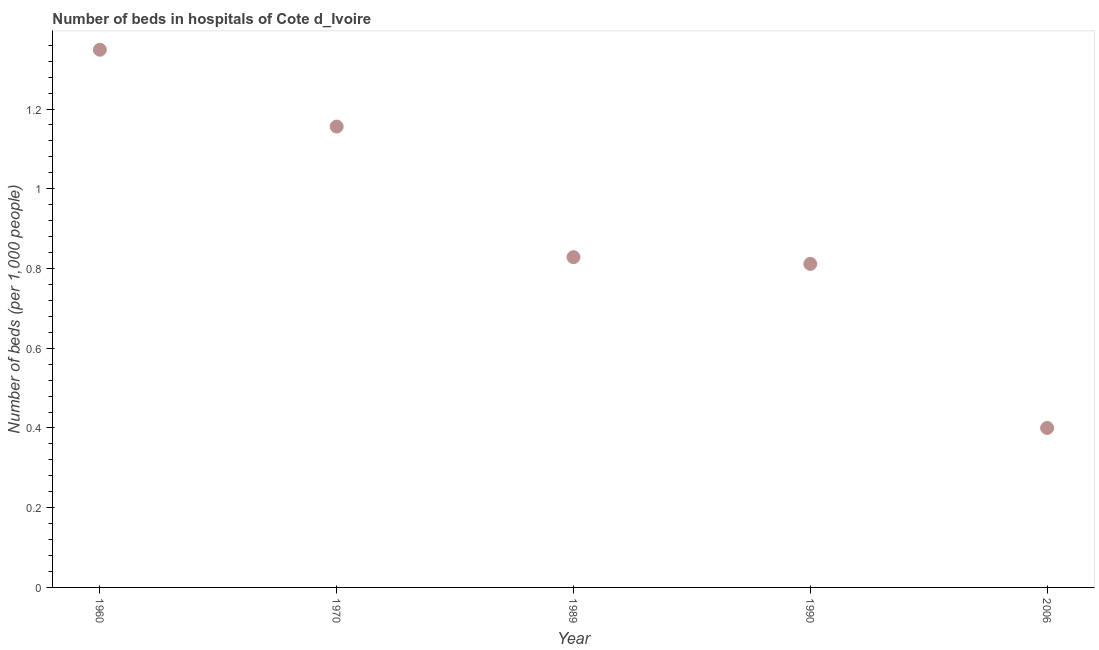What is the number of hospital beds in 1970?
Your answer should be compact. 1.16. Across all years, what is the maximum number of hospital beds?
Provide a short and direct response. 1.35. In which year was the number of hospital beds minimum?
Provide a short and direct response. 2006. What is the sum of the number of hospital beds?
Your answer should be very brief. 4.54. What is the difference between the number of hospital beds in 1990 and 2006?
Keep it short and to the point. 0.41. What is the average number of hospital beds per year?
Keep it short and to the point. 0.91. What is the median number of hospital beds?
Make the answer very short. 0.83. In how many years, is the number of hospital beds greater than 0.8 %?
Your response must be concise. 4. What is the ratio of the number of hospital beds in 1960 to that in 1970?
Your response must be concise. 1.17. Is the number of hospital beds in 1960 less than that in 1989?
Give a very brief answer. No. Is the difference between the number of hospital beds in 1970 and 1989 greater than the difference between any two years?
Your response must be concise. No. What is the difference between the highest and the second highest number of hospital beds?
Provide a short and direct response. 0.19. What is the difference between the highest and the lowest number of hospital beds?
Your answer should be very brief. 0.95. Does the number of hospital beds monotonically increase over the years?
Your response must be concise. No. What is the difference between two consecutive major ticks on the Y-axis?
Ensure brevity in your answer.  0.2. Are the values on the major ticks of Y-axis written in scientific E-notation?
Offer a very short reply. No. Does the graph contain grids?
Offer a terse response. No. What is the title of the graph?
Your answer should be compact. Number of beds in hospitals of Cote d_Ivoire. What is the label or title of the Y-axis?
Give a very brief answer. Number of beds (per 1,0 people). What is the Number of beds (per 1,000 people) in 1960?
Offer a very short reply. 1.35. What is the Number of beds (per 1,000 people) in 1970?
Your answer should be very brief. 1.16. What is the Number of beds (per 1,000 people) in 1989?
Give a very brief answer. 0.83. What is the Number of beds (per 1,000 people) in 1990?
Give a very brief answer. 0.81. What is the difference between the Number of beds (per 1,000 people) in 1960 and 1970?
Your response must be concise. 0.19. What is the difference between the Number of beds (per 1,000 people) in 1960 and 1989?
Offer a very short reply. 0.52. What is the difference between the Number of beds (per 1,000 people) in 1960 and 1990?
Provide a succinct answer. 0.54. What is the difference between the Number of beds (per 1,000 people) in 1960 and 2006?
Offer a terse response. 0.95. What is the difference between the Number of beds (per 1,000 people) in 1970 and 1989?
Ensure brevity in your answer.  0.33. What is the difference between the Number of beds (per 1,000 people) in 1970 and 1990?
Provide a succinct answer. 0.34. What is the difference between the Number of beds (per 1,000 people) in 1970 and 2006?
Ensure brevity in your answer.  0.76. What is the difference between the Number of beds (per 1,000 people) in 1989 and 1990?
Your answer should be compact. 0.02. What is the difference between the Number of beds (per 1,000 people) in 1989 and 2006?
Keep it short and to the point. 0.43. What is the difference between the Number of beds (per 1,000 people) in 1990 and 2006?
Your answer should be compact. 0.41. What is the ratio of the Number of beds (per 1,000 people) in 1960 to that in 1970?
Provide a succinct answer. 1.17. What is the ratio of the Number of beds (per 1,000 people) in 1960 to that in 1989?
Your response must be concise. 1.63. What is the ratio of the Number of beds (per 1,000 people) in 1960 to that in 1990?
Your answer should be very brief. 1.66. What is the ratio of the Number of beds (per 1,000 people) in 1960 to that in 2006?
Your answer should be compact. 3.37. What is the ratio of the Number of beds (per 1,000 people) in 1970 to that in 1989?
Provide a succinct answer. 1.4. What is the ratio of the Number of beds (per 1,000 people) in 1970 to that in 1990?
Your answer should be very brief. 1.42. What is the ratio of the Number of beds (per 1,000 people) in 1970 to that in 2006?
Your answer should be very brief. 2.89. What is the ratio of the Number of beds (per 1,000 people) in 1989 to that in 2006?
Ensure brevity in your answer.  2.07. What is the ratio of the Number of beds (per 1,000 people) in 1990 to that in 2006?
Your answer should be very brief. 2.03. 